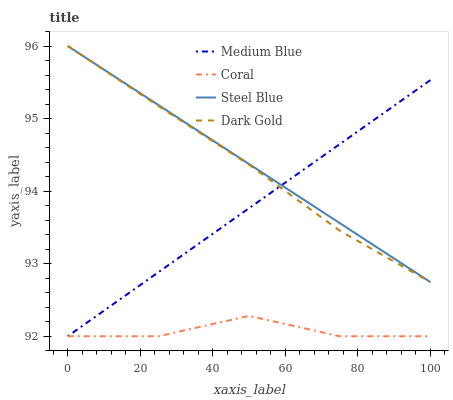Does Medium Blue have the minimum area under the curve?
Answer yes or no. No. Does Medium Blue have the maximum area under the curve?
Answer yes or no. No. Is Dark Gold the smoothest?
Answer yes or no. No. Is Dark Gold the roughest?
Answer yes or no. No. Does Steel Blue have the lowest value?
Answer yes or no. No. Does Medium Blue have the highest value?
Answer yes or no. No. Is Coral less than Dark Gold?
Answer yes or no. Yes. Is Steel Blue greater than Coral?
Answer yes or no. Yes. Does Coral intersect Dark Gold?
Answer yes or no. No. 